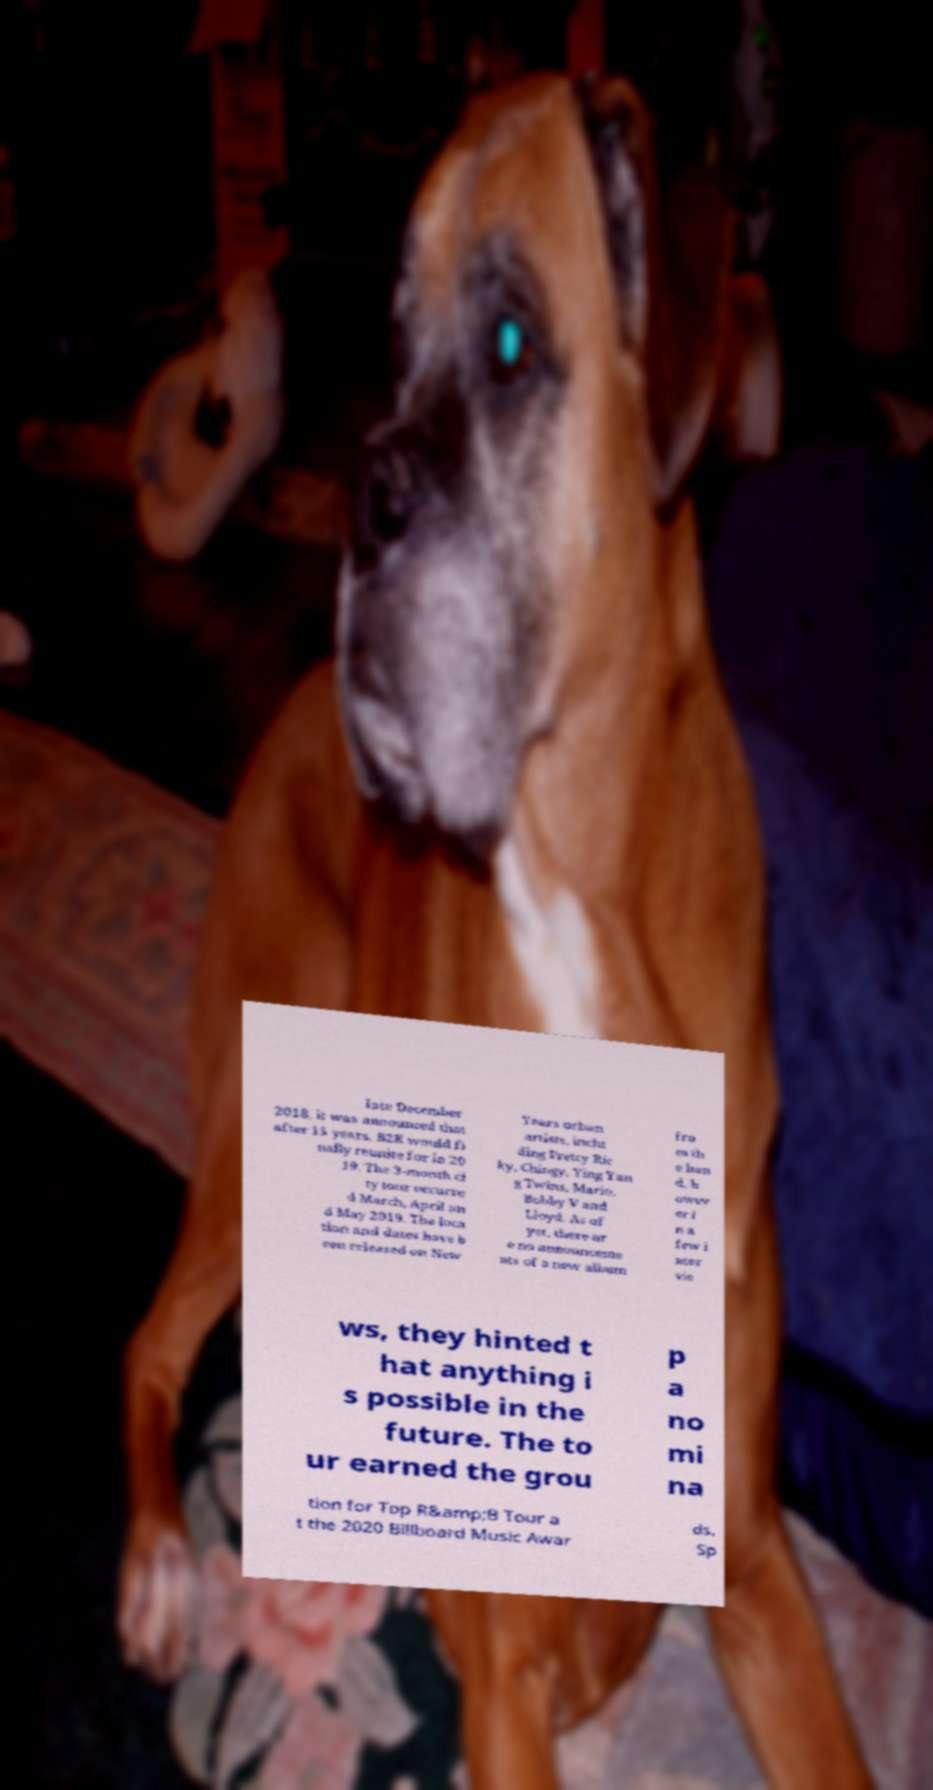There's text embedded in this image that I need extracted. Can you transcribe it verbatim? late December 2018, it was announced that after 15 years, B2K would fi nally reunite for in 20 19. The 3-month ci ty tour occurre d March, April an d May 2019. The loca tion and dates have b een released on New Years urban artists, inclu ding Pretty Ric ky, Chingy, Ying Yan g Twins, Mario, Bobby V and Lloyd. As of yet, there ar e no announceme nts of a new album fro m th e ban d, h owev er i n a few i nter vie ws, they hinted t hat anything i s possible in the future. The to ur earned the grou p a no mi na tion for Top R&amp;B Tour a t the 2020 Billboard Music Awar ds. Sp 